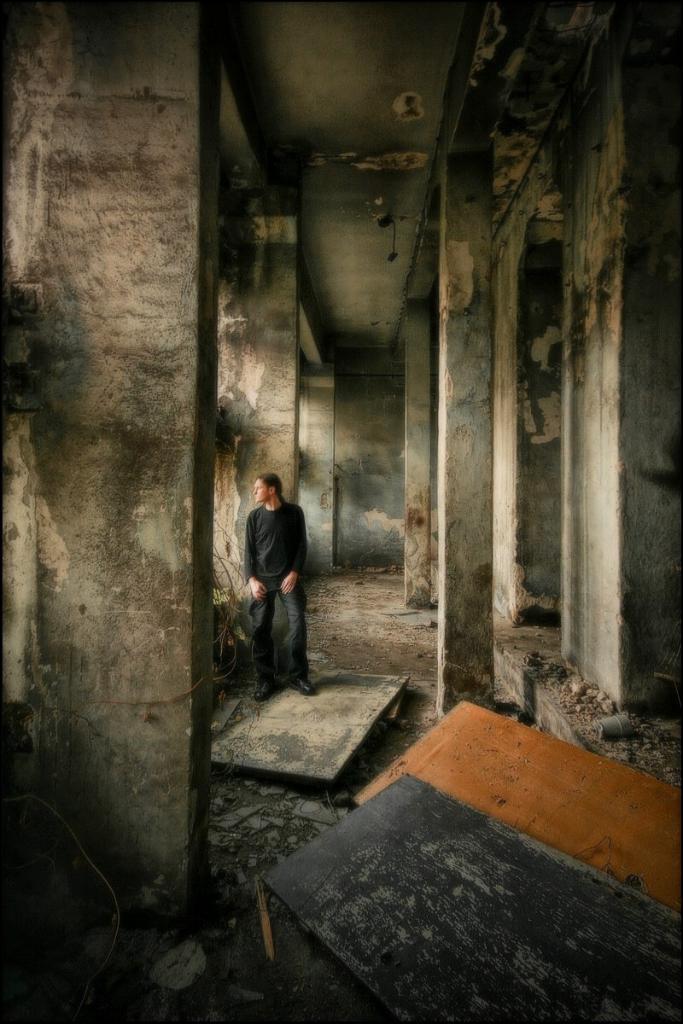Could you give a brief overview of what you see in this image? In this image, we can see a man standing, we can see the pillars and walls. We can see wooden doors on the ground. 